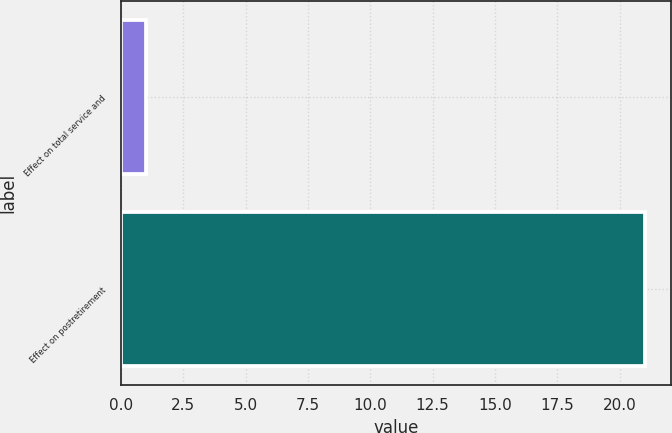Convert chart to OTSL. <chart><loc_0><loc_0><loc_500><loc_500><bar_chart><fcel>Effect on total service and<fcel>Effect on postretirement<nl><fcel>1<fcel>21<nl></chart> 